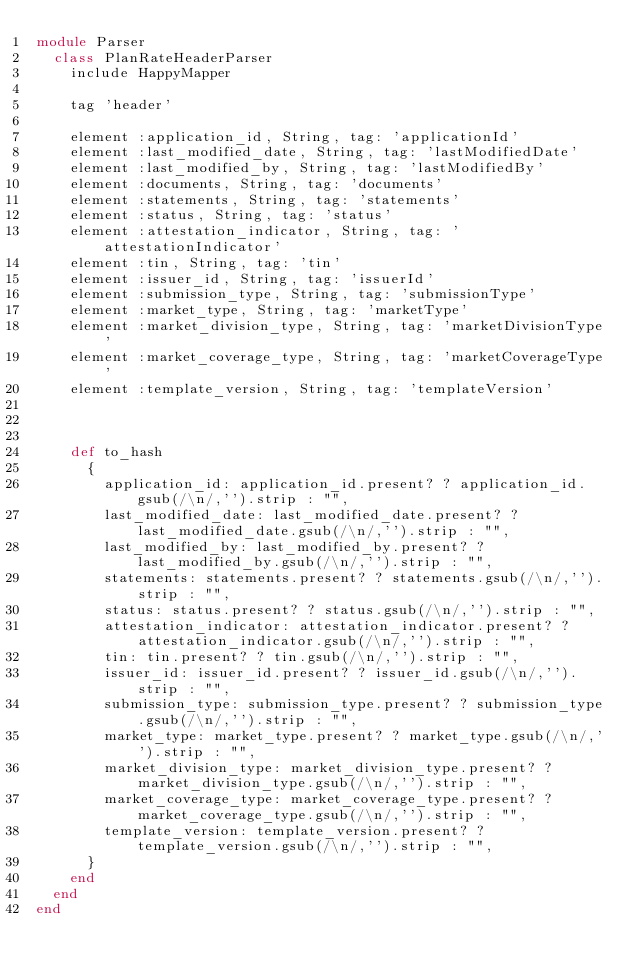Convert code to text. <code><loc_0><loc_0><loc_500><loc_500><_Ruby_>module Parser
  class PlanRateHeaderParser
    include HappyMapper

    tag 'header'

    element :application_id, String, tag: 'applicationId'
    element :last_modified_date, String, tag: 'lastModifiedDate'
    element :last_modified_by, String, tag: 'lastModifiedBy'
    element :documents, String, tag: 'documents'
    element :statements, String, tag: 'statements'
    element :status, String, tag: 'status'
    element :attestation_indicator, String, tag: 'attestationIndicator'
    element :tin, String, tag: 'tin'
    element :issuer_id, String, tag: 'issuerId'
    element :submission_type, String, tag: 'submissionType'
    element :market_type, String, tag: 'marketType'
    element :market_division_type, String, tag: 'marketDivisionType'
    element :market_coverage_type, String, tag: 'marketCoverageType'
    element :template_version, String, tag: 'templateVersion'



    def to_hash
      {
        application_id: application_id.present? ? application_id.gsub(/\n/,'').strip : "",
        last_modified_date: last_modified_date.present? ? last_modified_date.gsub(/\n/,'').strip : "",
        last_modified_by: last_modified_by.present? ? last_modified_by.gsub(/\n/,'').strip : "",
        statements: statements.present? ? statements.gsub(/\n/,'').strip : "",
        status: status.present? ? status.gsub(/\n/,'').strip : "",
        attestation_indicator: attestation_indicator.present? ? attestation_indicator.gsub(/\n/,'').strip : "",
        tin: tin.present? ? tin.gsub(/\n/,'').strip : "",
        issuer_id: issuer_id.present? ? issuer_id.gsub(/\n/,'').strip : "",
        submission_type: submission_type.present? ? submission_type.gsub(/\n/,'').strip : "",
        market_type: market_type.present? ? market_type.gsub(/\n/,'').strip : "",
        market_division_type: market_division_type.present? ? market_division_type.gsub(/\n/,'').strip : "",
        market_coverage_type: market_coverage_type.present? ? market_coverage_type.gsub(/\n/,'').strip : "",
        template_version: template_version.present? ? template_version.gsub(/\n/,'').strip : "",
      }
    end
  end
end</code> 